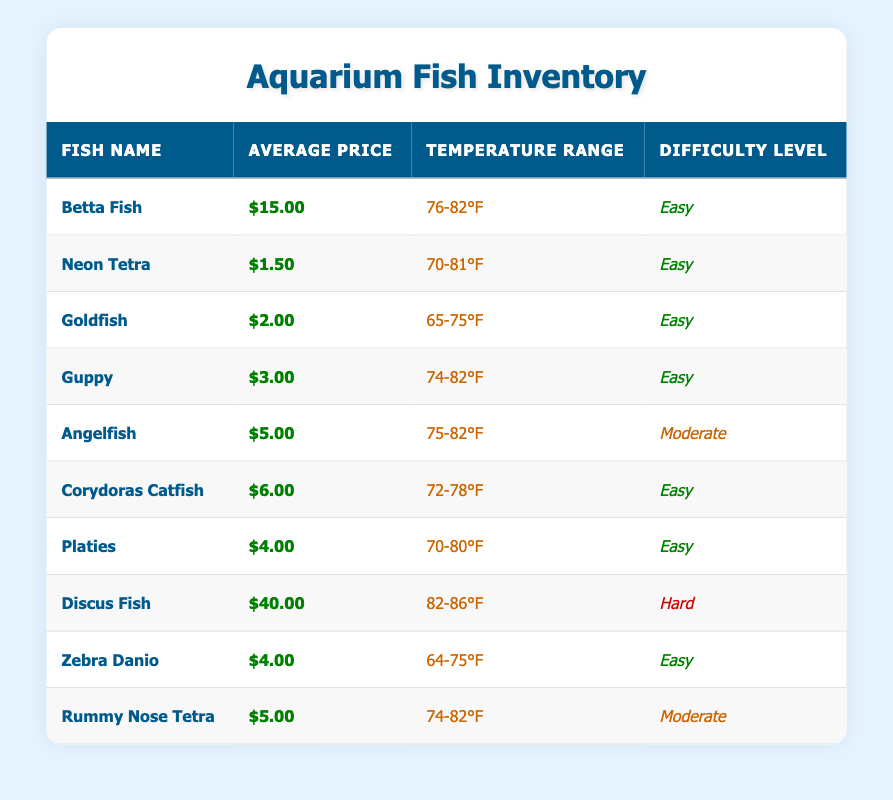What is the average price of a Neon Tetra? The average price of a Neon Tetra is listed in the table, directly under the Average Price column. It shows $1.50 for this fish.
Answer: $1.50 Which fish has the highest average price? The table lists the average prices of all the fish. By comparing, the Discus Fish is shown with the highest average price of $40.00.
Answer: Discus Fish How many fish have an average price below $5.00? From the table, we examine the Average Price column. The fish with average prices below $5.00 are Neon Tetra ($1.50), Goldfish ($2.00), Guppy ($3.00), Platies ($4.00), and Zebra Danio ($4.00). That totals 5 fish.
Answer: 5 Is Angelfish more expensive than Guppy? The average price for Angelfish is $5.00 and for Guppy it is $3.00. Since $5.00 is greater than $3.00, Angelfish is indeed more expensive than Guppy.
Answer: Yes What is the price difference between Betta Fish and Rummy Nose Tetra? Betta Fish costs $15.00 and Rummy Nose Tetra costs $5.00. To find the price difference, subtract the latter from the former: $15.00 - $5.00 = $10.00.
Answer: $10.00 Which fish has a temperature range of 74-82°F and is easy to care for? We need to check the Temperature Range and Difficulty Level columns. The fish matching both conditions are Guppy, Angelfish, and Rummy Nose Tetra.
Answer: Guppy, Angelfish, Rummy Nose Tetra How many fish are categorized as easy to keep? Referring to the Difficulty Level column, we can count: Betta Fish, Neon Tetra, Goldfish, Guppy, Corydoras Catfish, Platies, Zebra Danio. This sums up to 7 fish.
Answer: 7 What is the average price of the fish categorized as hard? The only fish classified as hard is Discus Fish, which costs $40.00. Since there's only one fish, that value is also the average.
Answer: $40.00 Is there any fish that requires a temperature range above 80°F and is easy to keep? The temperature range for easy fish should be checked against the table, and searching through shows no easy fish with a range higher than 80°F as the maximum is 82°F for Betta Fish and Guppy.
Answer: No 